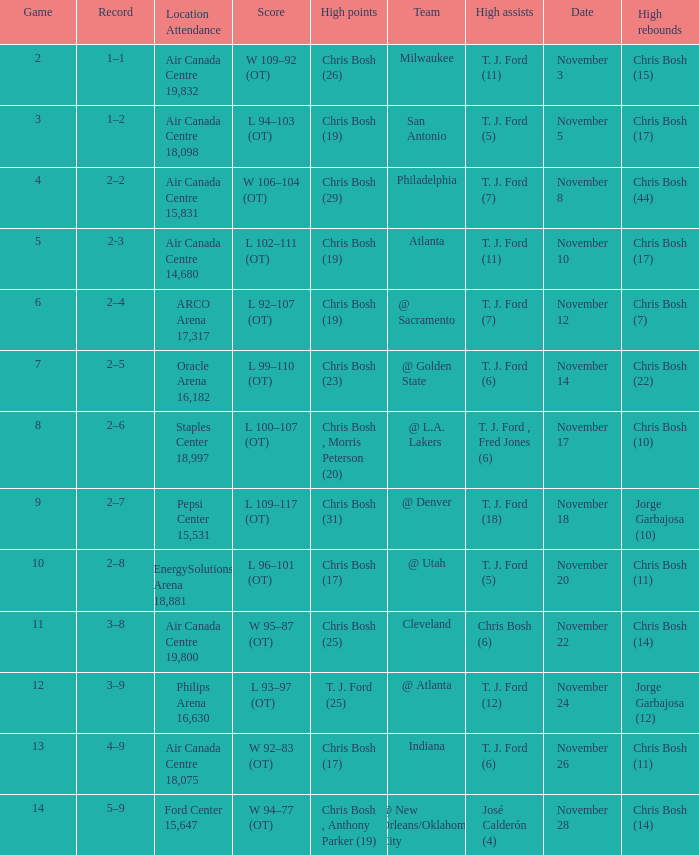Who scored the most points in game 4? Chris Bosh (29). 